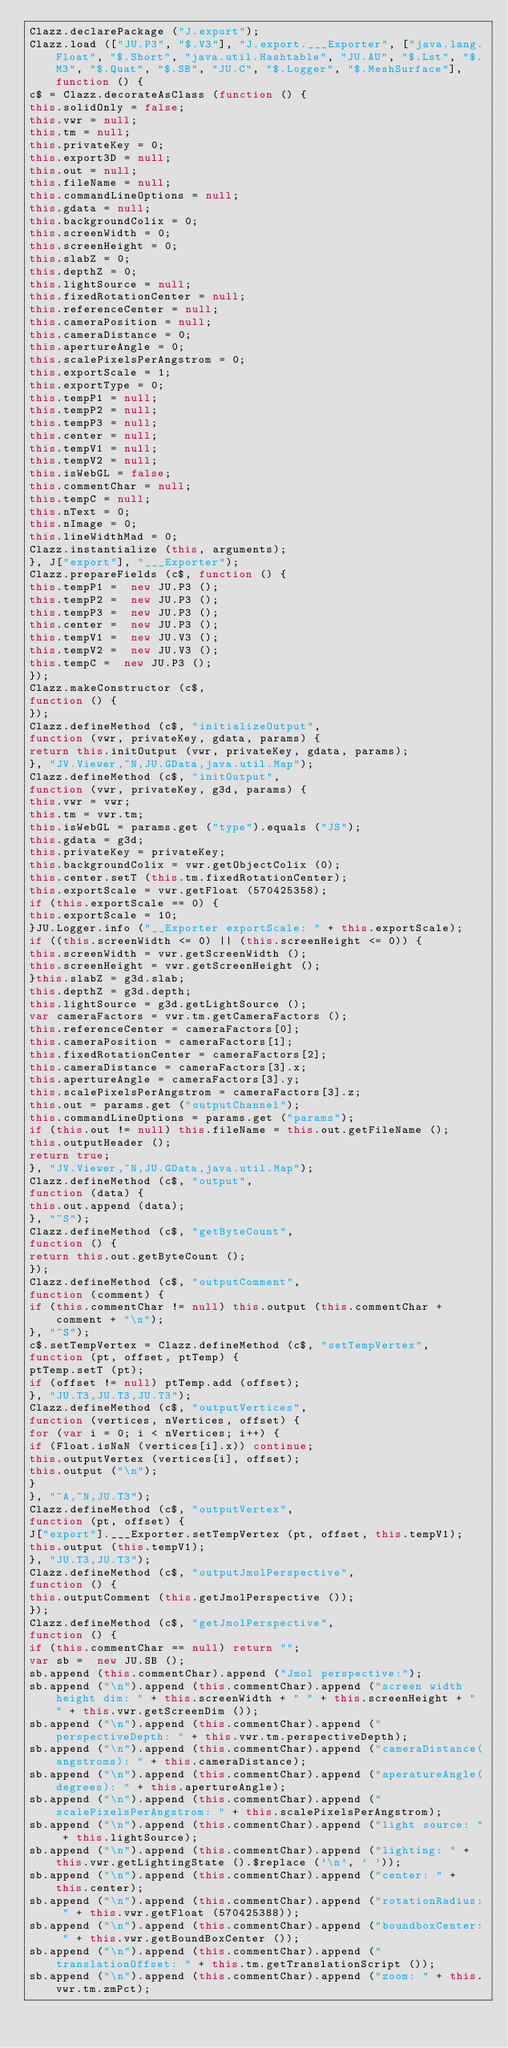Convert code to text. <code><loc_0><loc_0><loc_500><loc_500><_JavaScript_>Clazz.declarePackage ("J.export");
Clazz.load (["JU.P3", "$.V3"], "J.export.___Exporter", ["java.lang.Float", "$.Short", "java.util.Hashtable", "JU.AU", "$.Lst", "$.M3", "$.Quat", "$.SB", "JU.C", "$.Logger", "$.MeshSurface"], function () {
c$ = Clazz.decorateAsClass (function () {
this.solidOnly = false;
this.vwr = null;
this.tm = null;
this.privateKey = 0;
this.export3D = null;
this.out = null;
this.fileName = null;
this.commandLineOptions = null;
this.gdata = null;
this.backgroundColix = 0;
this.screenWidth = 0;
this.screenHeight = 0;
this.slabZ = 0;
this.depthZ = 0;
this.lightSource = null;
this.fixedRotationCenter = null;
this.referenceCenter = null;
this.cameraPosition = null;
this.cameraDistance = 0;
this.apertureAngle = 0;
this.scalePixelsPerAngstrom = 0;
this.exportScale = 1;
this.exportType = 0;
this.tempP1 = null;
this.tempP2 = null;
this.tempP3 = null;
this.center = null;
this.tempV1 = null;
this.tempV2 = null;
this.isWebGL = false;
this.commentChar = null;
this.tempC = null;
this.nText = 0;
this.nImage = 0;
this.lineWidthMad = 0;
Clazz.instantialize (this, arguments);
}, J["export"], "___Exporter");
Clazz.prepareFields (c$, function () {
this.tempP1 =  new JU.P3 ();
this.tempP2 =  new JU.P3 ();
this.tempP3 =  new JU.P3 ();
this.center =  new JU.P3 ();
this.tempV1 =  new JU.V3 ();
this.tempV2 =  new JU.V3 ();
this.tempC =  new JU.P3 ();
});
Clazz.makeConstructor (c$, 
function () {
});
Clazz.defineMethod (c$, "initializeOutput", 
function (vwr, privateKey, gdata, params) {
return this.initOutput (vwr, privateKey, gdata, params);
}, "JV.Viewer,~N,JU.GData,java.util.Map");
Clazz.defineMethod (c$, "initOutput", 
function (vwr, privateKey, g3d, params) {
this.vwr = vwr;
this.tm = vwr.tm;
this.isWebGL = params.get ("type").equals ("JS");
this.gdata = g3d;
this.privateKey = privateKey;
this.backgroundColix = vwr.getObjectColix (0);
this.center.setT (this.tm.fixedRotationCenter);
this.exportScale = vwr.getFloat (570425358);
if (this.exportScale == 0) {
this.exportScale = 10;
}JU.Logger.info ("__Exporter exportScale: " + this.exportScale);
if ((this.screenWidth <= 0) || (this.screenHeight <= 0)) {
this.screenWidth = vwr.getScreenWidth ();
this.screenHeight = vwr.getScreenHeight ();
}this.slabZ = g3d.slab;
this.depthZ = g3d.depth;
this.lightSource = g3d.getLightSource ();
var cameraFactors = vwr.tm.getCameraFactors ();
this.referenceCenter = cameraFactors[0];
this.cameraPosition = cameraFactors[1];
this.fixedRotationCenter = cameraFactors[2];
this.cameraDistance = cameraFactors[3].x;
this.apertureAngle = cameraFactors[3].y;
this.scalePixelsPerAngstrom = cameraFactors[3].z;
this.out = params.get ("outputChannel");
this.commandLineOptions = params.get ("params");
if (this.out != null) this.fileName = this.out.getFileName ();
this.outputHeader ();
return true;
}, "JV.Viewer,~N,JU.GData,java.util.Map");
Clazz.defineMethod (c$, "output", 
function (data) {
this.out.append (data);
}, "~S");
Clazz.defineMethod (c$, "getByteCount", 
function () {
return this.out.getByteCount ();
});
Clazz.defineMethod (c$, "outputComment", 
function (comment) {
if (this.commentChar != null) this.output (this.commentChar + comment + "\n");
}, "~S");
c$.setTempVertex = Clazz.defineMethod (c$, "setTempVertex", 
function (pt, offset, ptTemp) {
ptTemp.setT (pt);
if (offset != null) ptTemp.add (offset);
}, "JU.T3,JU.T3,JU.T3");
Clazz.defineMethod (c$, "outputVertices", 
function (vertices, nVertices, offset) {
for (var i = 0; i < nVertices; i++) {
if (Float.isNaN (vertices[i].x)) continue;
this.outputVertex (vertices[i], offset);
this.output ("\n");
}
}, "~A,~N,JU.T3");
Clazz.defineMethod (c$, "outputVertex", 
function (pt, offset) {
J["export"].___Exporter.setTempVertex (pt, offset, this.tempV1);
this.output (this.tempV1);
}, "JU.T3,JU.T3");
Clazz.defineMethod (c$, "outputJmolPerspective", 
function () {
this.outputComment (this.getJmolPerspective ());
});
Clazz.defineMethod (c$, "getJmolPerspective", 
function () {
if (this.commentChar == null) return "";
var sb =  new JU.SB ();
sb.append (this.commentChar).append ("Jmol perspective:");
sb.append ("\n").append (this.commentChar).append ("screen width height dim: " + this.screenWidth + " " + this.screenHeight + " " + this.vwr.getScreenDim ());
sb.append ("\n").append (this.commentChar).append ("perspectiveDepth: " + this.vwr.tm.perspectiveDepth);
sb.append ("\n").append (this.commentChar).append ("cameraDistance(angstroms): " + this.cameraDistance);
sb.append ("\n").append (this.commentChar).append ("aperatureAngle(degrees): " + this.apertureAngle);
sb.append ("\n").append (this.commentChar).append ("scalePixelsPerAngstrom: " + this.scalePixelsPerAngstrom);
sb.append ("\n").append (this.commentChar).append ("light source: " + this.lightSource);
sb.append ("\n").append (this.commentChar).append ("lighting: " + this.vwr.getLightingState ().$replace ('\n', ' '));
sb.append ("\n").append (this.commentChar).append ("center: " + this.center);
sb.append ("\n").append (this.commentChar).append ("rotationRadius: " + this.vwr.getFloat (570425388));
sb.append ("\n").append (this.commentChar).append ("boundboxCenter: " + this.vwr.getBoundBoxCenter ());
sb.append ("\n").append (this.commentChar).append ("translationOffset: " + this.tm.getTranslationScript ());
sb.append ("\n").append (this.commentChar).append ("zoom: " + this.vwr.tm.zmPct);</code> 